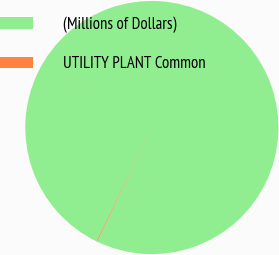Convert chart to OTSL. <chart><loc_0><loc_0><loc_500><loc_500><pie_chart><fcel>(Millions of Dollars)<fcel>UTILITY PLANT Common<nl><fcel>99.9%<fcel>0.1%<nl></chart> 